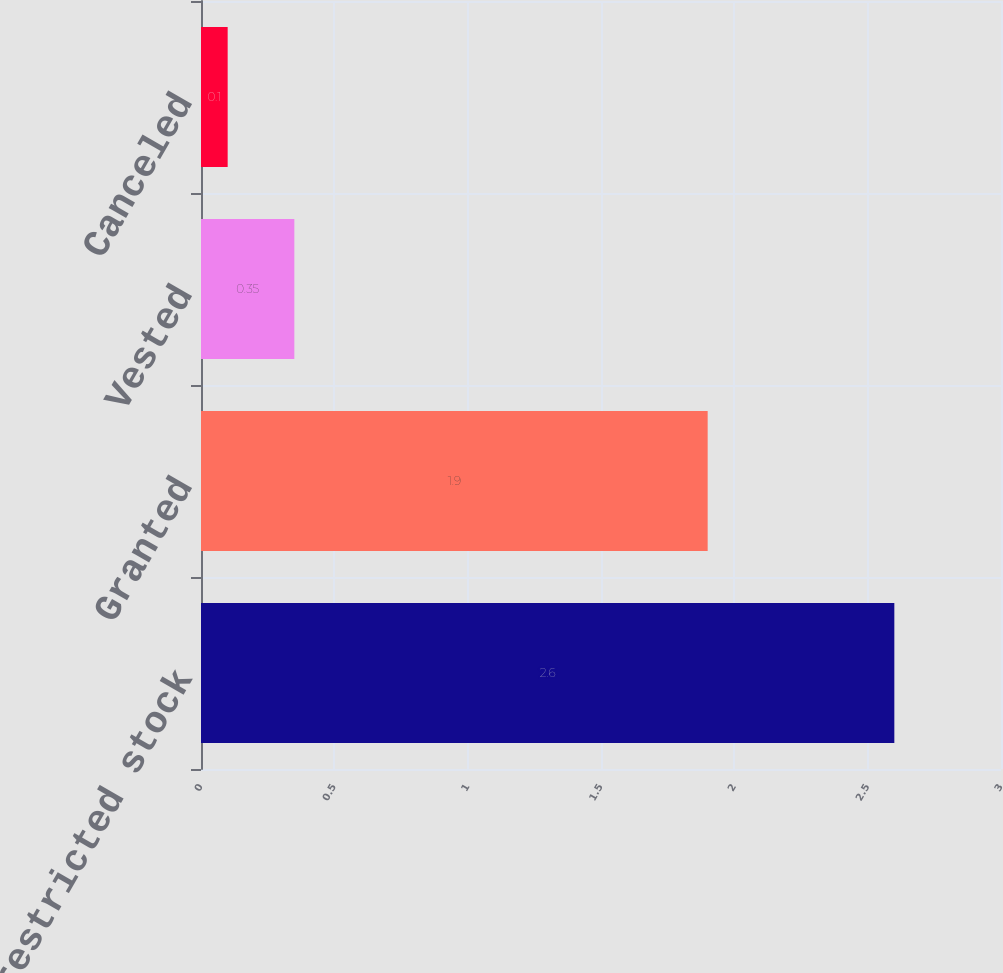Convert chart. <chart><loc_0><loc_0><loc_500><loc_500><bar_chart><fcel>Nonvested restricted stock<fcel>Granted<fcel>Vested<fcel>Canceled<nl><fcel>2.6<fcel>1.9<fcel>0.35<fcel>0.1<nl></chart> 